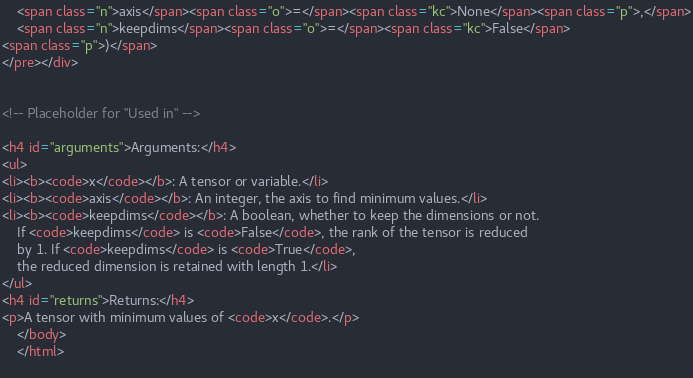Convert code to text. <code><loc_0><loc_0><loc_500><loc_500><_HTML_>    <span class="n">axis</span><span class="o">=</span><span class="kc">None</span><span class="p">,</span>
    <span class="n">keepdims</span><span class="o">=</span><span class="kc">False</span>
<span class="p">)</span>
</pre></div>


<!-- Placeholder for "Used in" -->

<h4 id="arguments">Arguments:</h4>
<ul>
<li><b><code>x</code></b>: A tensor or variable.</li>
<li><b><code>axis</code></b>: An integer, the axis to find minimum values.</li>
<li><b><code>keepdims</code></b>: A boolean, whether to keep the dimensions or not.
    If <code>keepdims</code> is <code>False</code>, the rank of the tensor is reduced
    by 1. If <code>keepdims</code> is <code>True</code>,
    the reduced dimension is retained with length 1.</li>
</ul>
<h4 id="returns">Returns:</h4>
<p>A tensor with minimum values of <code>x</code>.</p>
    </body>
    </html>
   </code> 